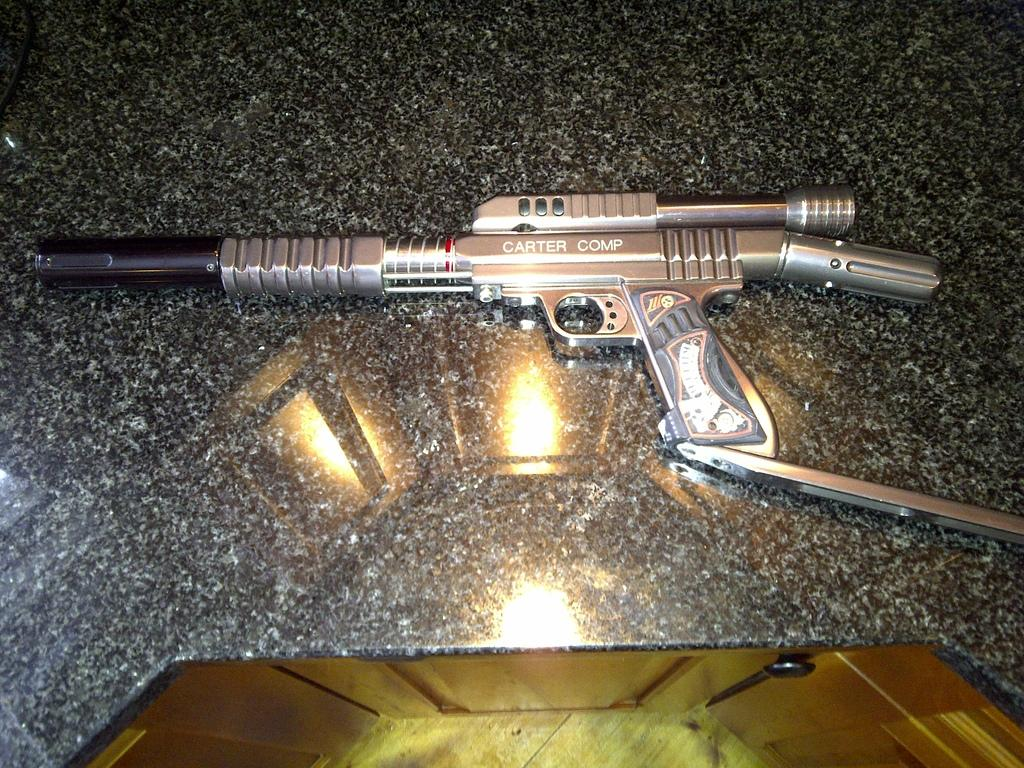What object can be seen on the floor in the image? There is a gun on the floor in the image. What type of acoustics can be heard coming from the kettle in the image? There is no kettle present in the image, so it is not possible to determine the acoustics. 